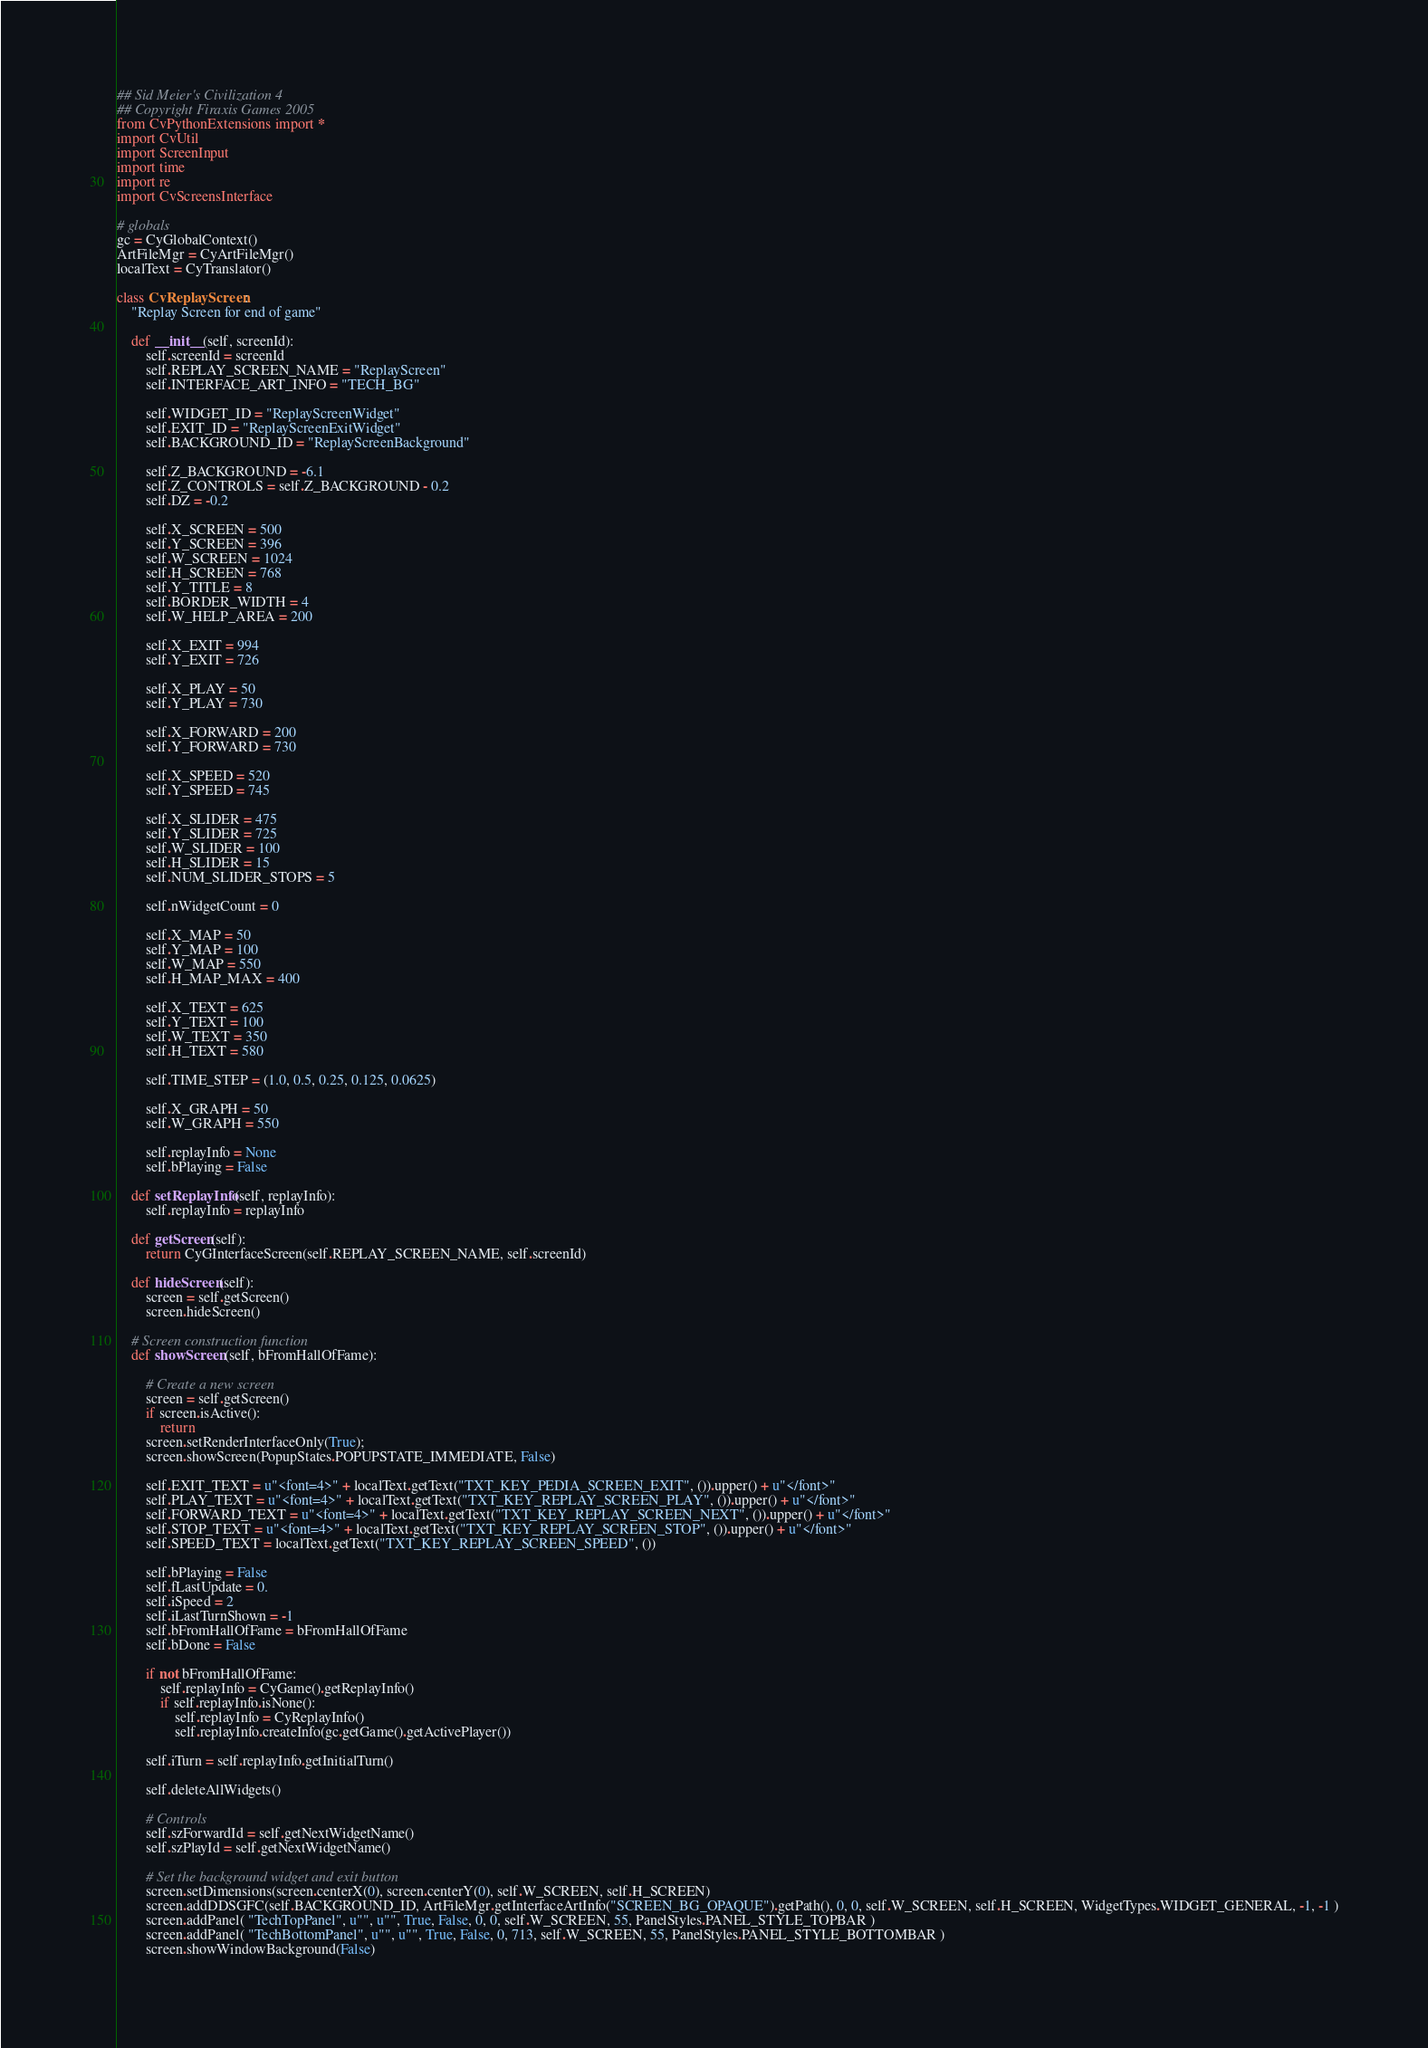<code> <loc_0><loc_0><loc_500><loc_500><_Python_>## Sid Meier's Civilization 4
## Copyright Firaxis Games 2005
from CvPythonExtensions import *
import CvUtil
import ScreenInput
import time
import re
import CvScreensInterface

# globals
gc = CyGlobalContext()
ArtFileMgr = CyArtFileMgr()
localText = CyTranslator()

class CvReplayScreen:
	"Replay Screen for end of game"

	def __init__(self, screenId):
		self.screenId = screenId
		self.REPLAY_SCREEN_NAME = "ReplayScreen"
		self.INTERFACE_ART_INFO = "TECH_BG"

		self.WIDGET_ID = "ReplayScreenWidget"
		self.EXIT_ID = "ReplayScreenExitWidget"
		self.BACKGROUND_ID = "ReplayScreenBackground"

		self.Z_BACKGROUND = -6.1
		self.Z_CONTROLS = self.Z_BACKGROUND - 0.2
		self.DZ = -0.2

		self.X_SCREEN = 500
		self.Y_SCREEN = 396
		self.W_SCREEN = 1024
		self.H_SCREEN = 768
		self.Y_TITLE = 8
		self.BORDER_WIDTH = 4
		self.W_HELP_AREA = 200
		
		self.X_EXIT = 994
		self.Y_EXIT = 726
						
		self.X_PLAY = 50
		self.Y_PLAY = 730

		self.X_FORWARD = 200
		self.Y_FORWARD = 730
		
		self.X_SPEED = 520
		self.Y_SPEED = 745
		
		self.X_SLIDER = 475
		self.Y_SLIDER = 725
		self.W_SLIDER = 100
		self.H_SLIDER = 15
		self.NUM_SLIDER_STOPS = 5
		
		self.nWidgetCount = 0
		
		self.X_MAP = 50
		self.Y_MAP = 100
		self.W_MAP = 550
		self.H_MAP_MAX = 400
		
		self.X_TEXT = 625
		self.Y_TEXT = 100
		self.W_TEXT = 350
		self.H_TEXT = 580
		
		self.TIME_STEP = (1.0, 0.5, 0.25, 0.125, 0.0625)
				
		self.X_GRAPH = 50
		self.W_GRAPH = 550
		
		self.replayInfo = None
		self.bPlaying = False
		
	def setReplayInfo(self, replayInfo):
		self.replayInfo = replayInfo
		
	def getScreen(self):
		return CyGInterfaceScreen(self.REPLAY_SCREEN_NAME, self.screenId)

	def hideScreen(self):
		screen = self.getScreen()
		screen.hideScreen()	
		
	# Screen construction function
	def showScreen(self, bFromHallOfFame):
	
		# Create a new screen
		screen = self.getScreen()
		if screen.isActive():
			return
		screen.setRenderInterfaceOnly(True);
		screen.showScreen(PopupStates.POPUPSTATE_IMMEDIATE, False)

		self.EXIT_TEXT = u"<font=4>" + localText.getText("TXT_KEY_PEDIA_SCREEN_EXIT", ()).upper() + u"</font>"
		self.PLAY_TEXT = u"<font=4>" + localText.getText("TXT_KEY_REPLAY_SCREEN_PLAY", ()).upper() + u"</font>"
		self.FORWARD_TEXT = u"<font=4>" + localText.getText("TXT_KEY_REPLAY_SCREEN_NEXT", ()).upper() + u"</font>"
		self.STOP_TEXT = u"<font=4>" + localText.getText("TXT_KEY_REPLAY_SCREEN_STOP", ()).upper() + u"</font>"
		self.SPEED_TEXT = localText.getText("TXT_KEY_REPLAY_SCREEN_SPEED", ())
			
		self.bPlaying = False
		self.fLastUpdate = 0.
		self.iSpeed = 2
		self.iLastTurnShown = -1
		self.bFromHallOfFame = bFromHallOfFame
		self.bDone = False
		
		if not bFromHallOfFame:
			self.replayInfo = CyGame().getReplayInfo()
			if self.replayInfo.isNone():
				self.replayInfo = CyReplayInfo()
				self.replayInfo.createInfo(gc.getGame().getActivePlayer())
				
		self.iTurn = self.replayInfo.getInitialTurn()
					
		self.deleteAllWidgets()
	
		# Controls
		self.szForwardId = self.getNextWidgetName()
		self.szPlayId = self.getNextWidgetName()
		
		# Set the background widget and exit button
		screen.setDimensions(screen.centerX(0), screen.centerY(0), self.W_SCREEN, self.H_SCREEN)
		screen.addDDSGFC(self.BACKGROUND_ID, ArtFileMgr.getInterfaceArtInfo("SCREEN_BG_OPAQUE").getPath(), 0, 0, self.W_SCREEN, self.H_SCREEN, WidgetTypes.WIDGET_GENERAL, -1, -1 )
		screen.addPanel( "TechTopPanel", u"", u"", True, False, 0, 0, self.W_SCREEN, 55, PanelStyles.PANEL_STYLE_TOPBAR )
		screen.addPanel( "TechBottomPanel", u"", u"", True, False, 0, 713, self.W_SCREEN, 55, PanelStyles.PANEL_STYLE_BOTTOMBAR )
		screen.showWindowBackground(False)</code> 